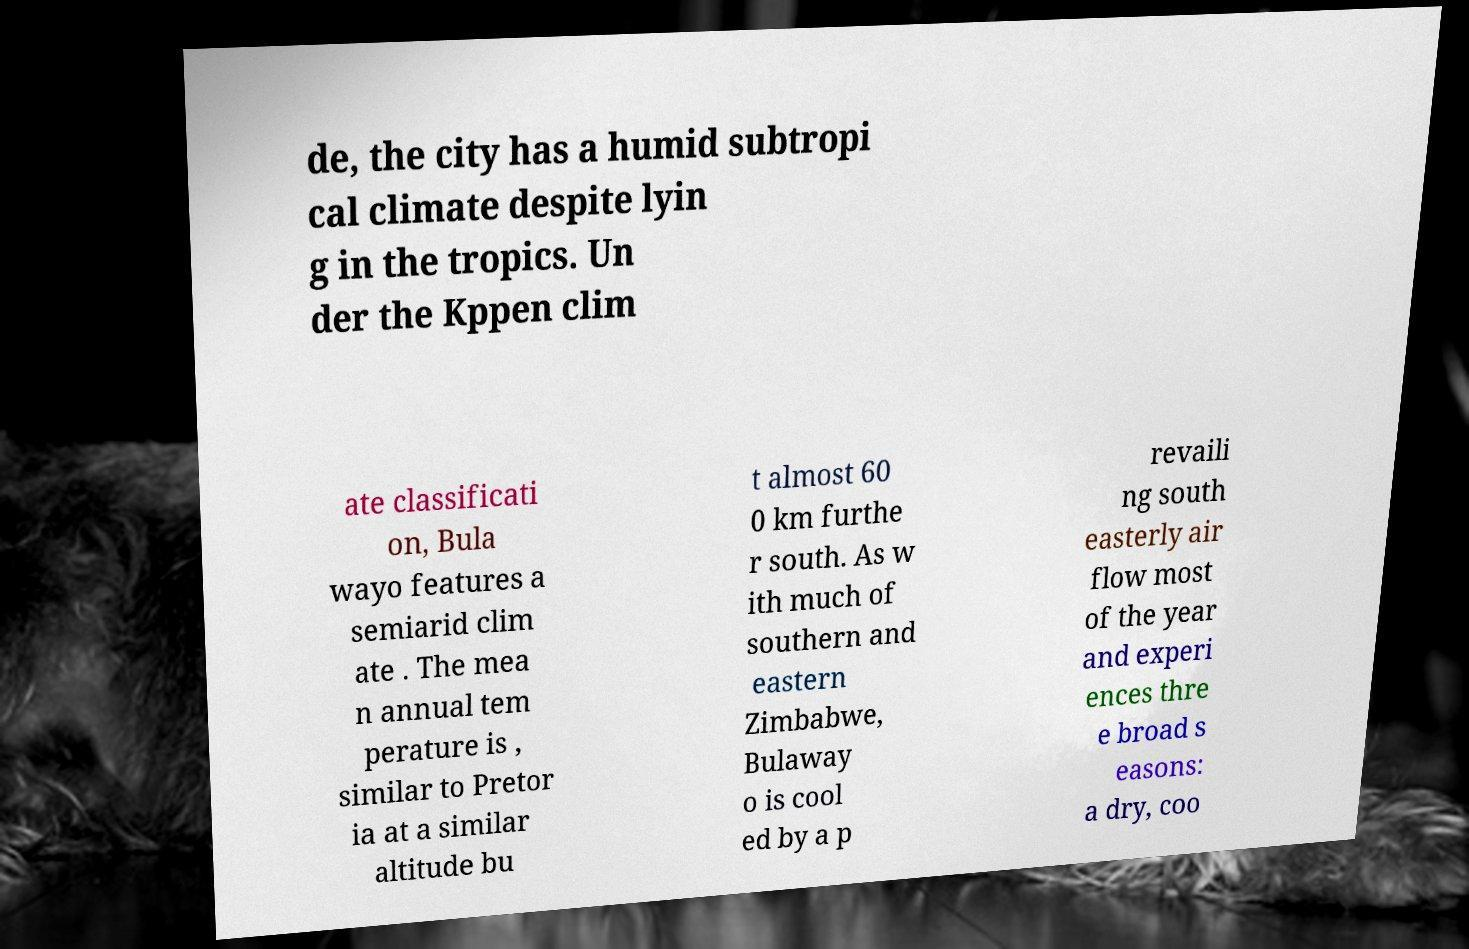I need the written content from this picture converted into text. Can you do that? de, the city has a humid subtropi cal climate despite lyin g in the tropics. Un der the Kppen clim ate classificati on, Bula wayo features a semiarid clim ate . The mea n annual tem perature is , similar to Pretor ia at a similar altitude bu t almost 60 0 km furthe r south. As w ith much of southern and eastern Zimbabwe, Bulaway o is cool ed by a p revaili ng south easterly air flow most of the year and experi ences thre e broad s easons: a dry, coo 